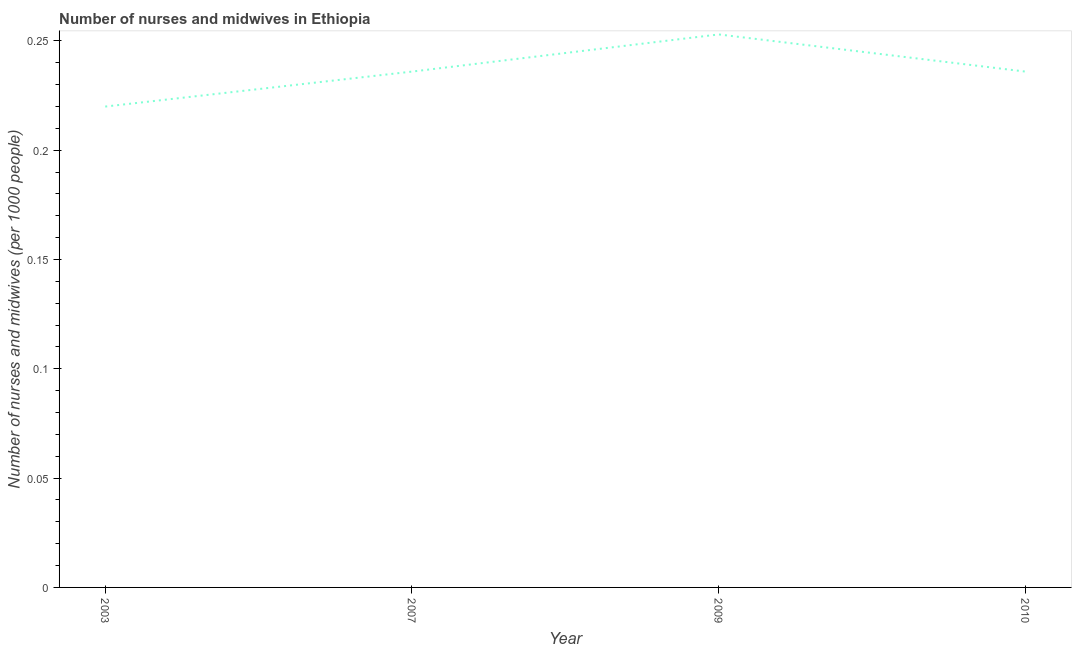What is the number of nurses and midwives in 2007?
Your answer should be very brief. 0.24. Across all years, what is the maximum number of nurses and midwives?
Ensure brevity in your answer.  0.25. Across all years, what is the minimum number of nurses and midwives?
Keep it short and to the point. 0.22. In which year was the number of nurses and midwives maximum?
Provide a succinct answer. 2009. In which year was the number of nurses and midwives minimum?
Provide a succinct answer. 2003. What is the sum of the number of nurses and midwives?
Your response must be concise. 0.94. What is the average number of nurses and midwives per year?
Your answer should be very brief. 0.24. What is the median number of nurses and midwives?
Your answer should be compact. 0.24. What is the ratio of the number of nurses and midwives in 2003 to that in 2010?
Give a very brief answer. 0.93. What is the difference between the highest and the second highest number of nurses and midwives?
Keep it short and to the point. 0.02. What is the difference between the highest and the lowest number of nurses and midwives?
Make the answer very short. 0.03. Does the number of nurses and midwives monotonically increase over the years?
Your response must be concise. No. How many lines are there?
Provide a succinct answer. 1. What is the difference between two consecutive major ticks on the Y-axis?
Provide a short and direct response. 0.05. Are the values on the major ticks of Y-axis written in scientific E-notation?
Offer a terse response. No. Does the graph contain grids?
Your answer should be compact. No. What is the title of the graph?
Keep it short and to the point. Number of nurses and midwives in Ethiopia. What is the label or title of the X-axis?
Offer a very short reply. Year. What is the label or title of the Y-axis?
Make the answer very short. Number of nurses and midwives (per 1000 people). What is the Number of nurses and midwives (per 1000 people) of 2003?
Your answer should be very brief. 0.22. What is the Number of nurses and midwives (per 1000 people) of 2007?
Make the answer very short. 0.24. What is the Number of nurses and midwives (per 1000 people) of 2009?
Offer a terse response. 0.25. What is the Number of nurses and midwives (per 1000 people) of 2010?
Give a very brief answer. 0.24. What is the difference between the Number of nurses and midwives (per 1000 people) in 2003 and 2007?
Keep it short and to the point. -0.02. What is the difference between the Number of nurses and midwives (per 1000 people) in 2003 and 2009?
Your answer should be very brief. -0.03. What is the difference between the Number of nurses and midwives (per 1000 people) in 2003 and 2010?
Provide a short and direct response. -0.02. What is the difference between the Number of nurses and midwives (per 1000 people) in 2007 and 2009?
Give a very brief answer. -0.02. What is the difference between the Number of nurses and midwives (per 1000 people) in 2007 and 2010?
Offer a very short reply. 0. What is the difference between the Number of nurses and midwives (per 1000 people) in 2009 and 2010?
Your answer should be compact. 0.02. What is the ratio of the Number of nurses and midwives (per 1000 people) in 2003 to that in 2007?
Offer a terse response. 0.93. What is the ratio of the Number of nurses and midwives (per 1000 people) in 2003 to that in 2009?
Provide a succinct answer. 0.87. What is the ratio of the Number of nurses and midwives (per 1000 people) in 2003 to that in 2010?
Provide a short and direct response. 0.93. What is the ratio of the Number of nurses and midwives (per 1000 people) in 2007 to that in 2009?
Provide a short and direct response. 0.93. What is the ratio of the Number of nurses and midwives (per 1000 people) in 2007 to that in 2010?
Give a very brief answer. 1. What is the ratio of the Number of nurses and midwives (per 1000 people) in 2009 to that in 2010?
Make the answer very short. 1.07. 